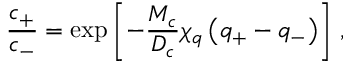<formula> <loc_0><loc_0><loc_500><loc_500>\frac { c _ { + } } { c _ { - } } = \exp \left [ - \frac { M _ { c } } { D _ { c } } \chi _ { q } \left ( q _ { + } - q _ { - } \right ) \right ] \, ,</formula> 